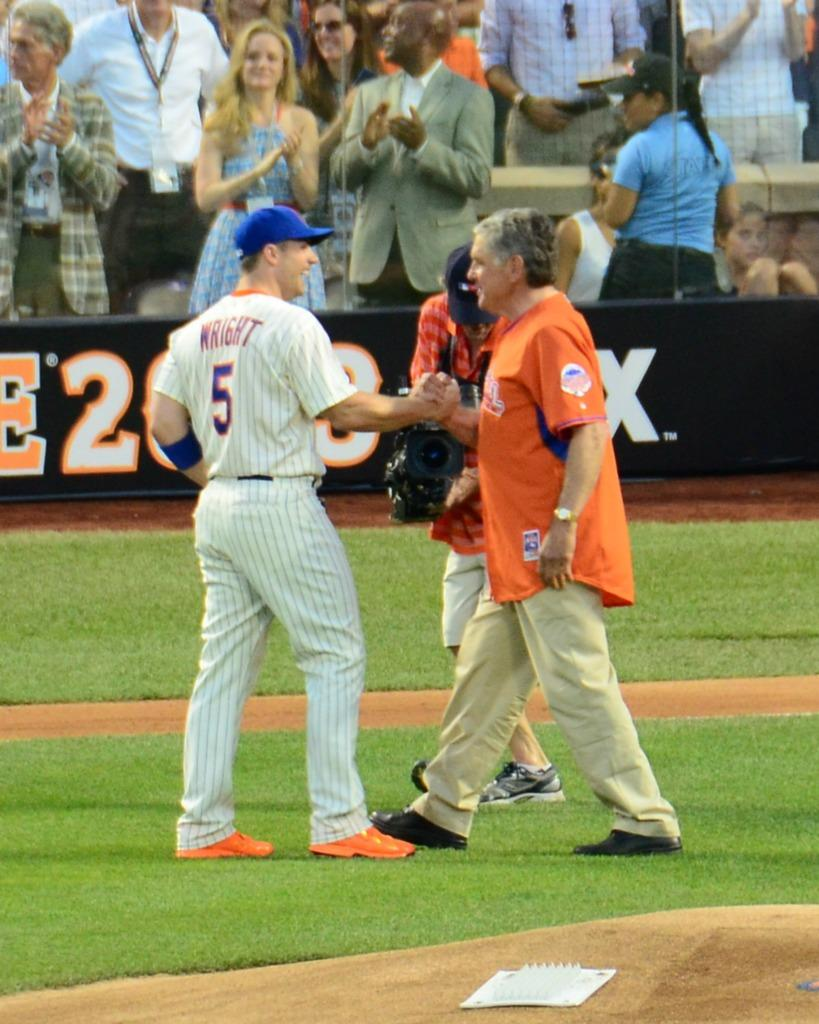Provide a one-sentence caption for the provided image. A baseball game is going on with fans watching and the player WRIGHT #5 grasping the hand of another man in the field. 